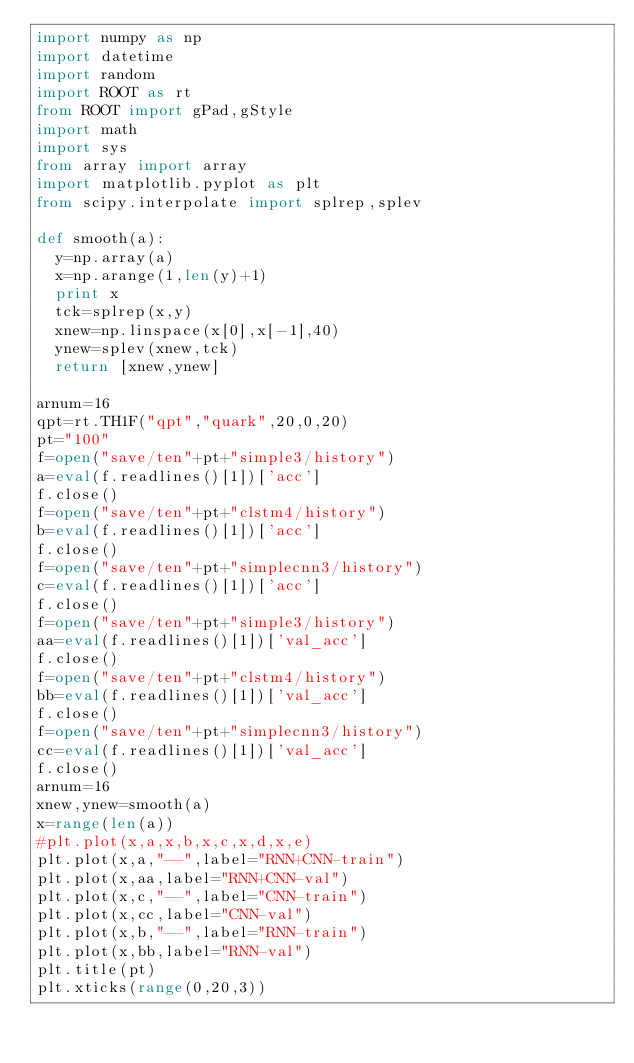Convert code to text. <code><loc_0><loc_0><loc_500><loc_500><_Python_>import numpy as np
import datetime
import random
import ROOT as rt
from ROOT import gPad,gStyle
import math
import sys
from array import array
import matplotlib.pyplot as plt
from scipy.interpolate import splrep,splev

def smooth(a):
  y=np.array(a)
  x=np.arange(1,len(y)+1)
  print x
  tck=splrep(x,y)
  xnew=np.linspace(x[0],x[-1],40)
  ynew=splev(xnew,tck)
  return [xnew,ynew]

arnum=16
qpt=rt.TH1F("qpt","quark",20,0,20)
pt="100"
f=open("save/ten"+pt+"simple3/history")
a=eval(f.readlines()[1])['acc']
f.close()
f=open("save/ten"+pt+"clstm4/history")
b=eval(f.readlines()[1])['acc']
f.close()
f=open("save/ten"+pt+"simplecnn3/history")
c=eval(f.readlines()[1])['acc']
f.close()
f=open("save/ten"+pt+"simple3/history")
aa=eval(f.readlines()[1])['val_acc']
f.close()
f=open("save/ten"+pt+"clstm4/history")
bb=eval(f.readlines()[1])['val_acc']
f.close()
f=open("save/ten"+pt+"simplecnn3/history")
cc=eval(f.readlines()[1])['val_acc']
f.close()
arnum=16
xnew,ynew=smooth(a)
x=range(len(a))
#plt.plot(x,a,x,b,x,c,x,d,x,e)
plt.plot(x,a,"--",label="RNN+CNN-train")
plt.plot(x,aa,label="RNN+CNN-val")
plt.plot(x,c,"--",label="CNN-train")
plt.plot(x,cc,label="CNN-val")
plt.plot(x,b,"--",label="RNN-train")
plt.plot(x,bb,label="RNN-val")
plt.title(pt)
plt.xticks(range(0,20,3))</code> 